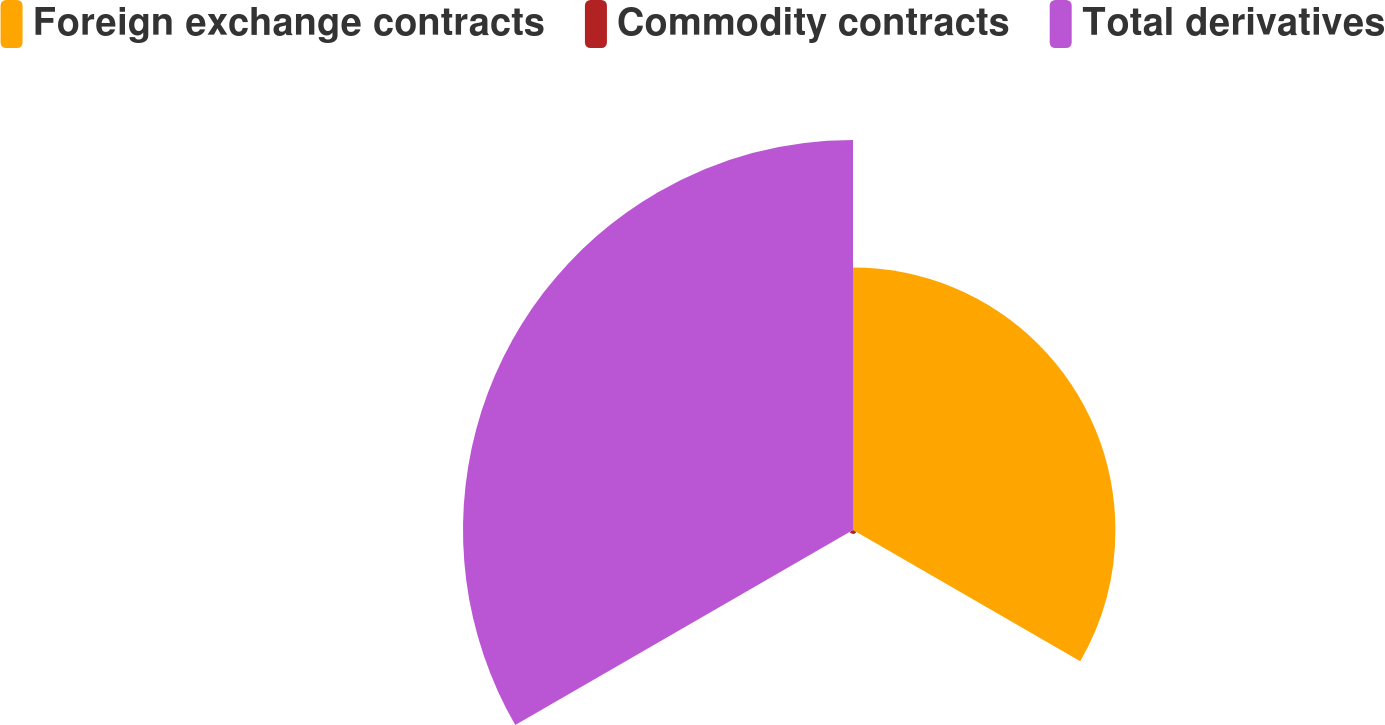Convert chart to OTSL. <chart><loc_0><loc_0><loc_500><loc_500><pie_chart><fcel>Foreign exchange contracts<fcel>Commodity contracts<fcel>Total derivatives<nl><fcel>39.99%<fcel>0.59%<fcel>59.43%<nl></chart> 